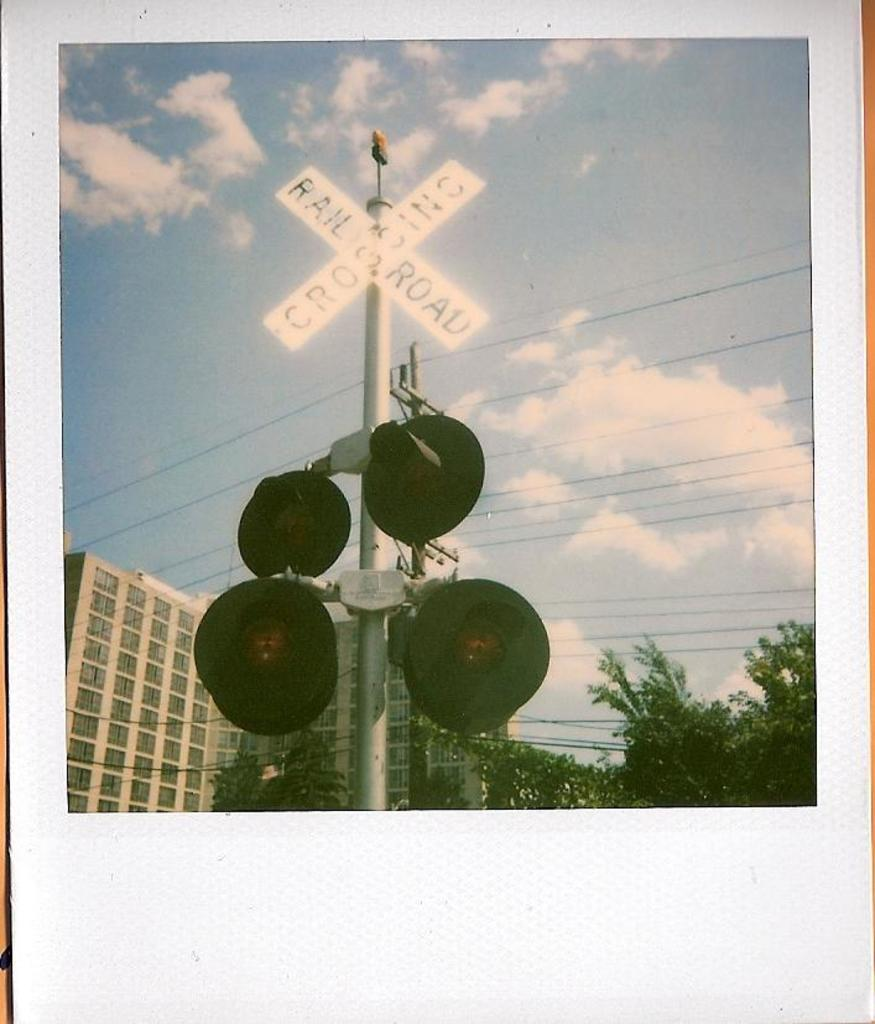What is the main subject of the image? There is a photo in the image. What can be seen in the photo? The photo contains a pole. What is attached to the pole? There are sign boards and lights on the pole. What can be seen in the background of the photo? There are buildings, trees, and the sky visible behind the pole. What type of brass instrument is being played by the waves in the image? There is no brass instrument or waves present in the image. 